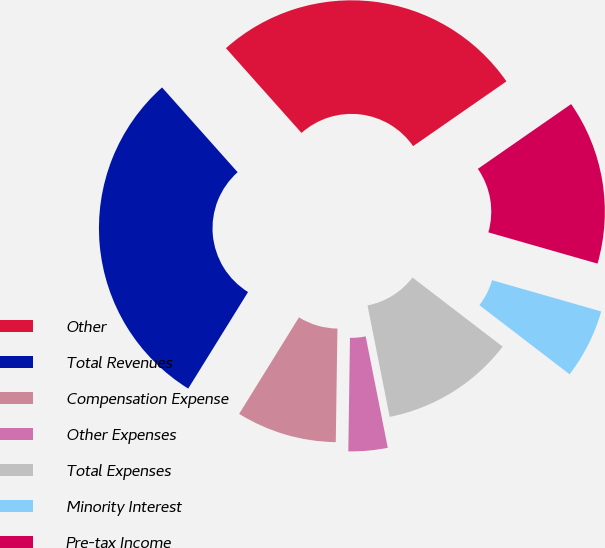Convert chart to OTSL. <chart><loc_0><loc_0><loc_500><loc_500><pie_chart><fcel>Other<fcel>Total Revenues<fcel>Compensation Expense<fcel>Other Expenses<fcel>Total Expenses<fcel>Minority Interest<fcel>Pre-tax Income<nl><fcel>26.93%<fcel>29.58%<fcel>8.6%<fcel>3.35%<fcel>11.47%<fcel>5.97%<fcel>14.1%<nl></chart> 